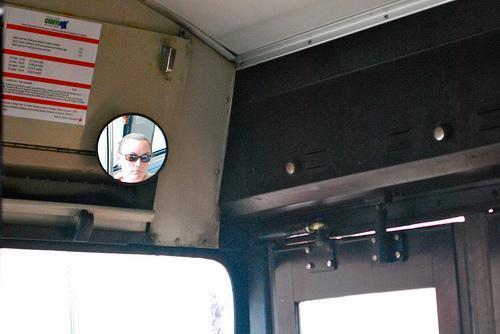How many mirrors are there?
Give a very brief answer. 1. 